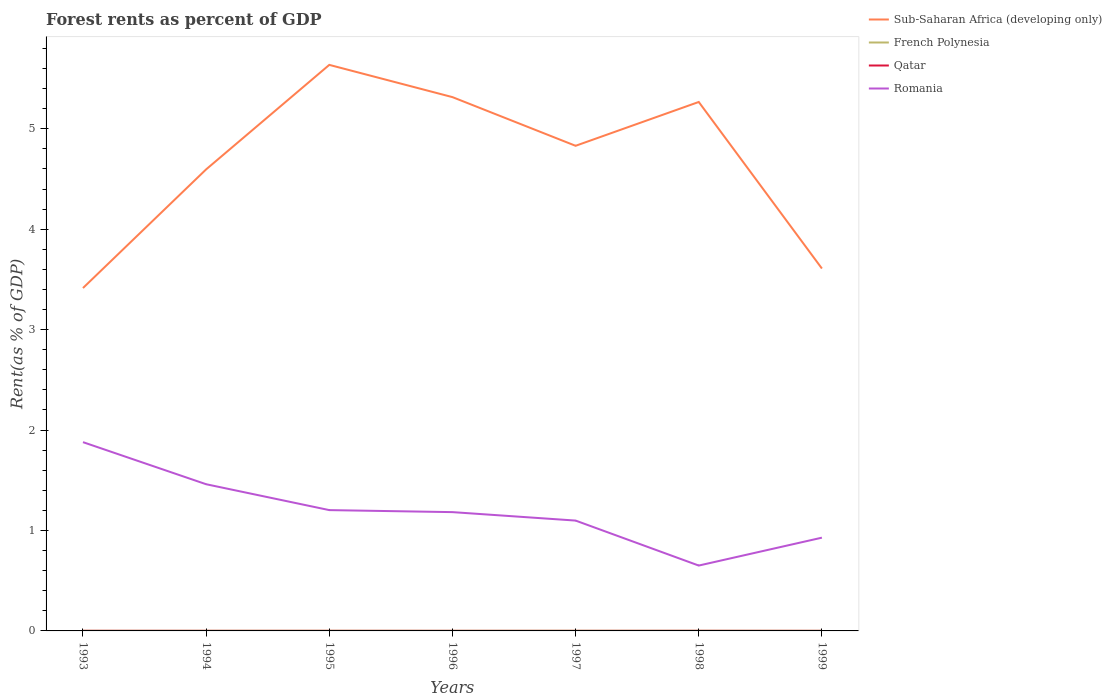Across all years, what is the maximum forest rent in French Polynesia?
Your answer should be compact. 0. In which year was the forest rent in French Polynesia maximum?
Provide a short and direct response. 1993. What is the total forest rent in Qatar in the graph?
Your answer should be compact. 0. What is the difference between the highest and the second highest forest rent in French Polynesia?
Provide a succinct answer. 0. Is the forest rent in Sub-Saharan Africa (developing only) strictly greater than the forest rent in Romania over the years?
Keep it short and to the point. No. How many lines are there?
Make the answer very short. 4. How many years are there in the graph?
Your response must be concise. 7. What is the difference between two consecutive major ticks on the Y-axis?
Give a very brief answer. 1. Are the values on the major ticks of Y-axis written in scientific E-notation?
Offer a very short reply. No. Does the graph contain any zero values?
Offer a terse response. No. How many legend labels are there?
Your response must be concise. 4. How are the legend labels stacked?
Your answer should be compact. Vertical. What is the title of the graph?
Offer a terse response. Forest rents as percent of GDP. Does "Cuba" appear as one of the legend labels in the graph?
Provide a succinct answer. No. What is the label or title of the Y-axis?
Your response must be concise. Rent(as % of GDP). What is the Rent(as % of GDP) of Sub-Saharan Africa (developing only) in 1993?
Your response must be concise. 3.41. What is the Rent(as % of GDP) in French Polynesia in 1993?
Give a very brief answer. 0. What is the Rent(as % of GDP) in Qatar in 1993?
Make the answer very short. 0. What is the Rent(as % of GDP) in Romania in 1993?
Give a very brief answer. 1.88. What is the Rent(as % of GDP) of Sub-Saharan Africa (developing only) in 1994?
Keep it short and to the point. 4.6. What is the Rent(as % of GDP) in French Polynesia in 1994?
Your answer should be compact. 0. What is the Rent(as % of GDP) of Qatar in 1994?
Provide a succinct answer. 0. What is the Rent(as % of GDP) of Romania in 1994?
Offer a very short reply. 1.46. What is the Rent(as % of GDP) of Sub-Saharan Africa (developing only) in 1995?
Your answer should be very brief. 5.64. What is the Rent(as % of GDP) of French Polynesia in 1995?
Offer a very short reply. 0. What is the Rent(as % of GDP) in Qatar in 1995?
Your answer should be very brief. 0. What is the Rent(as % of GDP) of Romania in 1995?
Give a very brief answer. 1.2. What is the Rent(as % of GDP) of Sub-Saharan Africa (developing only) in 1996?
Provide a short and direct response. 5.32. What is the Rent(as % of GDP) in French Polynesia in 1996?
Provide a succinct answer. 0. What is the Rent(as % of GDP) of Qatar in 1996?
Your answer should be compact. 0. What is the Rent(as % of GDP) in Romania in 1996?
Offer a terse response. 1.18. What is the Rent(as % of GDP) of Sub-Saharan Africa (developing only) in 1997?
Your response must be concise. 4.83. What is the Rent(as % of GDP) in French Polynesia in 1997?
Make the answer very short. 0. What is the Rent(as % of GDP) of Qatar in 1997?
Offer a terse response. 0. What is the Rent(as % of GDP) in Romania in 1997?
Provide a short and direct response. 1.1. What is the Rent(as % of GDP) of Sub-Saharan Africa (developing only) in 1998?
Your response must be concise. 5.27. What is the Rent(as % of GDP) in French Polynesia in 1998?
Your answer should be compact. 0. What is the Rent(as % of GDP) in Qatar in 1998?
Your answer should be very brief. 0. What is the Rent(as % of GDP) in Romania in 1998?
Ensure brevity in your answer.  0.65. What is the Rent(as % of GDP) in Sub-Saharan Africa (developing only) in 1999?
Offer a terse response. 3.61. What is the Rent(as % of GDP) in French Polynesia in 1999?
Ensure brevity in your answer.  0. What is the Rent(as % of GDP) of Qatar in 1999?
Give a very brief answer. 0. What is the Rent(as % of GDP) of Romania in 1999?
Offer a very short reply. 0.93. Across all years, what is the maximum Rent(as % of GDP) of Sub-Saharan Africa (developing only)?
Your response must be concise. 5.64. Across all years, what is the maximum Rent(as % of GDP) in French Polynesia?
Offer a terse response. 0. Across all years, what is the maximum Rent(as % of GDP) in Qatar?
Keep it short and to the point. 0. Across all years, what is the maximum Rent(as % of GDP) of Romania?
Give a very brief answer. 1.88. Across all years, what is the minimum Rent(as % of GDP) in Sub-Saharan Africa (developing only)?
Make the answer very short. 3.41. Across all years, what is the minimum Rent(as % of GDP) of French Polynesia?
Ensure brevity in your answer.  0. Across all years, what is the minimum Rent(as % of GDP) of Qatar?
Offer a terse response. 0. Across all years, what is the minimum Rent(as % of GDP) in Romania?
Your response must be concise. 0.65. What is the total Rent(as % of GDP) in Sub-Saharan Africa (developing only) in the graph?
Your answer should be compact. 32.67. What is the total Rent(as % of GDP) of French Polynesia in the graph?
Provide a succinct answer. 0.01. What is the total Rent(as % of GDP) in Qatar in the graph?
Keep it short and to the point. 0.01. What is the total Rent(as % of GDP) in Romania in the graph?
Your response must be concise. 8.4. What is the difference between the Rent(as % of GDP) of Sub-Saharan Africa (developing only) in 1993 and that in 1994?
Make the answer very short. -1.18. What is the difference between the Rent(as % of GDP) in French Polynesia in 1993 and that in 1994?
Give a very brief answer. -0. What is the difference between the Rent(as % of GDP) of Qatar in 1993 and that in 1994?
Keep it short and to the point. 0. What is the difference between the Rent(as % of GDP) of Romania in 1993 and that in 1994?
Offer a very short reply. 0.42. What is the difference between the Rent(as % of GDP) in Sub-Saharan Africa (developing only) in 1993 and that in 1995?
Provide a short and direct response. -2.22. What is the difference between the Rent(as % of GDP) in French Polynesia in 1993 and that in 1995?
Offer a terse response. -0. What is the difference between the Rent(as % of GDP) of Qatar in 1993 and that in 1995?
Give a very brief answer. 0. What is the difference between the Rent(as % of GDP) in Romania in 1993 and that in 1995?
Make the answer very short. 0.68. What is the difference between the Rent(as % of GDP) of Sub-Saharan Africa (developing only) in 1993 and that in 1996?
Ensure brevity in your answer.  -1.9. What is the difference between the Rent(as % of GDP) in French Polynesia in 1993 and that in 1996?
Your answer should be very brief. -0. What is the difference between the Rent(as % of GDP) of Qatar in 1993 and that in 1996?
Your response must be concise. 0. What is the difference between the Rent(as % of GDP) in Romania in 1993 and that in 1996?
Your answer should be very brief. 0.7. What is the difference between the Rent(as % of GDP) of Sub-Saharan Africa (developing only) in 1993 and that in 1997?
Make the answer very short. -1.42. What is the difference between the Rent(as % of GDP) in French Polynesia in 1993 and that in 1997?
Make the answer very short. -0. What is the difference between the Rent(as % of GDP) in Romania in 1993 and that in 1997?
Provide a succinct answer. 0.78. What is the difference between the Rent(as % of GDP) of Sub-Saharan Africa (developing only) in 1993 and that in 1998?
Provide a short and direct response. -1.85. What is the difference between the Rent(as % of GDP) of French Polynesia in 1993 and that in 1998?
Ensure brevity in your answer.  -0. What is the difference between the Rent(as % of GDP) in Romania in 1993 and that in 1998?
Keep it short and to the point. 1.23. What is the difference between the Rent(as % of GDP) of Sub-Saharan Africa (developing only) in 1993 and that in 1999?
Offer a very short reply. -0.19. What is the difference between the Rent(as % of GDP) in French Polynesia in 1993 and that in 1999?
Provide a succinct answer. -0. What is the difference between the Rent(as % of GDP) of Qatar in 1993 and that in 1999?
Keep it short and to the point. 0. What is the difference between the Rent(as % of GDP) in Romania in 1993 and that in 1999?
Give a very brief answer. 0.95. What is the difference between the Rent(as % of GDP) of Sub-Saharan Africa (developing only) in 1994 and that in 1995?
Your answer should be very brief. -1.04. What is the difference between the Rent(as % of GDP) of French Polynesia in 1994 and that in 1995?
Ensure brevity in your answer.  -0. What is the difference between the Rent(as % of GDP) of Qatar in 1994 and that in 1995?
Offer a very short reply. -0. What is the difference between the Rent(as % of GDP) of Romania in 1994 and that in 1995?
Make the answer very short. 0.26. What is the difference between the Rent(as % of GDP) in Sub-Saharan Africa (developing only) in 1994 and that in 1996?
Your response must be concise. -0.72. What is the difference between the Rent(as % of GDP) of Qatar in 1994 and that in 1996?
Offer a very short reply. 0. What is the difference between the Rent(as % of GDP) in Romania in 1994 and that in 1996?
Make the answer very short. 0.28. What is the difference between the Rent(as % of GDP) of Sub-Saharan Africa (developing only) in 1994 and that in 1997?
Offer a very short reply. -0.23. What is the difference between the Rent(as % of GDP) of French Polynesia in 1994 and that in 1997?
Give a very brief answer. -0. What is the difference between the Rent(as % of GDP) of Romania in 1994 and that in 1997?
Your answer should be very brief. 0.36. What is the difference between the Rent(as % of GDP) in Sub-Saharan Africa (developing only) in 1994 and that in 1998?
Keep it short and to the point. -0.67. What is the difference between the Rent(as % of GDP) of French Polynesia in 1994 and that in 1998?
Keep it short and to the point. -0. What is the difference between the Rent(as % of GDP) of Qatar in 1994 and that in 1998?
Your response must be concise. -0. What is the difference between the Rent(as % of GDP) in Romania in 1994 and that in 1998?
Offer a terse response. 0.81. What is the difference between the Rent(as % of GDP) in Sub-Saharan Africa (developing only) in 1994 and that in 1999?
Keep it short and to the point. 0.99. What is the difference between the Rent(as % of GDP) in French Polynesia in 1994 and that in 1999?
Your response must be concise. 0. What is the difference between the Rent(as % of GDP) in Qatar in 1994 and that in 1999?
Your answer should be very brief. 0. What is the difference between the Rent(as % of GDP) of Romania in 1994 and that in 1999?
Offer a terse response. 0.53. What is the difference between the Rent(as % of GDP) of Sub-Saharan Africa (developing only) in 1995 and that in 1996?
Provide a short and direct response. 0.32. What is the difference between the Rent(as % of GDP) of Qatar in 1995 and that in 1996?
Offer a very short reply. 0. What is the difference between the Rent(as % of GDP) of Romania in 1995 and that in 1996?
Provide a succinct answer. 0.02. What is the difference between the Rent(as % of GDP) of Sub-Saharan Africa (developing only) in 1995 and that in 1997?
Give a very brief answer. 0.81. What is the difference between the Rent(as % of GDP) in French Polynesia in 1995 and that in 1997?
Give a very brief answer. -0. What is the difference between the Rent(as % of GDP) of Qatar in 1995 and that in 1997?
Provide a succinct answer. 0. What is the difference between the Rent(as % of GDP) of Romania in 1995 and that in 1997?
Give a very brief answer. 0.1. What is the difference between the Rent(as % of GDP) in Sub-Saharan Africa (developing only) in 1995 and that in 1998?
Your answer should be compact. 0.37. What is the difference between the Rent(as % of GDP) of French Polynesia in 1995 and that in 1998?
Keep it short and to the point. -0. What is the difference between the Rent(as % of GDP) in Qatar in 1995 and that in 1998?
Your response must be concise. -0. What is the difference between the Rent(as % of GDP) of Romania in 1995 and that in 1998?
Provide a succinct answer. 0.55. What is the difference between the Rent(as % of GDP) of Sub-Saharan Africa (developing only) in 1995 and that in 1999?
Your answer should be compact. 2.03. What is the difference between the Rent(as % of GDP) of Qatar in 1995 and that in 1999?
Make the answer very short. 0. What is the difference between the Rent(as % of GDP) of Romania in 1995 and that in 1999?
Offer a terse response. 0.27. What is the difference between the Rent(as % of GDP) of Sub-Saharan Africa (developing only) in 1996 and that in 1997?
Give a very brief answer. 0.48. What is the difference between the Rent(as % of GDP) in French Polynesia in 1996 and that in 1997?
Give a very brief answer. -0. What is the difference between the Rent(as % of GDP) in Qatar in 1996 and that in 1997?
Keep it short and to the point. 0. What is the difference between the Rent(as % of GDP) of Romania in 1996 and that in 1997?
Make the answer very short. 0.08. What is the difference between the Rent(as % of GDP) in Sub-Saharan Africa (developing only) in 1996 and that in 1998?
Make the answer very short. 0.05. What is the difference between the Rent(as % of GDP) in French Polynesia in 1996 and that in 1998?
Your response must be concise. -0. What is the difference between the Rent(as % of GDP) of Qatar in 1996 and that in 1998?
Your answer should be very brief. -0. What is the difference between the Rent(as % of GDP) of Romania in 1996 and that in 1998?
Your answer should be compact. 0.53. What is the difference between the Rent(as % of GDP) of Sub-Saharan Africa (developing only) in 1996 and that in 1999?
Your response must be concise. 1.71. What is the difference between the Rent(as % of GDP) in French Polynesia in 1996 and that in 1999?
Offer a terse response. 0. What is the difference between the Rent(as % of GDP) in Qatar in 1996 and that in 1999?
Ensure brevity in your answer.  0. What is the difference between the Rent(as % of GDP) of Romania in 1996 and that in 1999?
Offer a terse response. 0.25. What is the difference between the Rent(as % of GDP) in Sub-Saharan Africa (developing only) in 1997 and that in 1998?
Your answer should be compact. -0.44. What is the difference between the Rent(as % of GDP) in Qatar in 1997 and that in 1998?
Offer a very short reply. -0. What is the difference between the Rent(as % of GDP) of Romania in 1997 and that in 1998?
Make the answer very short. 0.45. What is the difference between the Rent(as % of GDP) of Sub-Saharan Africa (developing only) in 1997 and that in 1999?
Offer a very short reply. 1.22. What is the difference between the Rent(as % of GDP) in French Polynesia in 1997 and that in 1999?
Ensure brevity in your answer.  0. What is the difference between the Rent(as % of GDP) in Romania in 1997 and that in 1999?
Your answer should be compact. 0.17. What is the difference between the Rent(as % of GDP) in Sub-Saharan Africa (developing only) in 1998 and that in 1999?
Provide a short and direct response. 1.66. What is the difference between the Rent(as % of GDP) in Qatar in 1998 and that in 1999?
Ensure brevity in your answer.  0. What is the difference between the Rent(as % of GDP) of Romania in 1998 and that in 1999?
Your answer should be very brief. -0.28. What is the difference between the Rent(as % of GDP) of Sub-Saharan Africa (developing only) in 1993 and the Rent(as % of GDP) of French Polynesia in 1994?
Keep it short and to the point. 3.41. What is the difference between the Rent(as % of GDP) of Sub-Saharan Africa (developing only) in 1993 and the Rent(as % of GDP) of Qatar in 1994?
Offer a terse response. 3.41. What is the difference between the Rent(as % of GDP) in Sub-Saharan Africa (developing only) in 1993 and the Rent(as % of GDP) in Romania in 1994?
Ensure brevity in your answer.  1.95. What is the difference between the Rent(as % of GDP) of French Polynesia in 1993 and the Rent(as % of GDP) of Romania in 1994?
Keep it short and to the point. -1.46. What is the difference between the Rent(as % of GDP) of Qatar in 1993 and the Rent(as % of GDP) of Romania in 1994?
Keep it short and to the point. -1.46. What is the difference between the Rent(as % of GDP) in Sub-Saharan Africa (developing only) in 1993 and the Rent(as % of GDP) in French Polynesia in 1995?
Your response must be concise. 3.41. What is the difference between the Rent(as % of GDP) in Sub-Saharan Africa (developing only) in 1993 and the Rent(as % of GDP) in Qatar in 1995?
Your answer should be very brief. 3.41. What is the difference between the Rent(as % of GDP) in Sub-Saharan Africa (developing only) in 1993 and the Rent(as % of GDP) in Romania in 1995?
Ensure brevity in your answer.  2.21. What is the difference between the Rent(as % of GDP) in French Polynesia in 1993 and the Rent(as % of GDP) in Romania in 1995?
Make the answer very short. -1.2. What is the difference between the Rent(as % of GDP) in Qatar in 1993 and the Rent(as % of GDP) in Romania in 1995?
Give a very brief answer. -1.2. What is the difference between the Rent(as % of GDP) in Sub-Saharan Africa (developing only) in 1993 and the Rent(as % of GDP) in French Polynesia in 1996?
Offer a terse response. 3.41. What is the difference between the Rent(as % of GDP) in Sub-Saharan Africa (developing only) in 1993 and the Rent(as % of GDP) in Qatar in 1996?
Offer a terse response. 3.41. What is the difference between the Rent(as % of GDP) in Sub-Saharan Africa (developing only) in 1993 and the Rent(as % of GDP) in Romania in 1996?
Give a very brief answer. 2.23. What is the difference between the Rent(as % of GDP) of French Polynesia in 1993 and the Rent(as % of GDP) of Qatar in 1996?
Provide a succinct answer. 0. What is the difference between the Rent(as % of GDP) in French Polynesia in 1993 and the Rent(as % of GDP) in Romania in 1996?
Give a very brief answer. -1.18. What is the difference between the Rent(as % of GDP) in Qatar in 1993 and the Rent(as % of GDP) in Romania in 1996?
Provide a succinct answer. -1.18. What is the difference between the Rent(as % of GDP) in Sub-Saharan Africa (developing only) in 1993 and the Rent(as % of GDP) in French Polynesia in 1997?
Your response must be concise. 3.41. What is the difference between the Rent(as % of GDP) of Sub-Saharan Africa (developing only) in 1993 and the Rent(as % of GDP) of Qatar in 1997?
Your answer should be very brief. 3.41. What is the difference between the Rent(as % of GDP) in Sub-Saharan Africa (developing only) in 1993 and the Rent(as % of GDP) in Romania in 1997?
Your answer should be compact. 2.32. What is the difference between the Rent(as % of GDP) of French Polynesia in 1993 and the Rent(as % of GDP) of Qatar in 1997?
Your answer should be very brief. 0. What is the difference between the Rent(as % of GDP) in French Polynesia in 1993 and the Rent(as % of GDP) in Romania in 1997?
Make the answer very short. -1.1. What is the difference between the Rent(as % of GDP) in Qatar in 1993 and the Rent(as % of GDP) in Romania in 1997?
Your response must be concise. -1.1. What is the difference between the Rent(as % of GDP) of Sub-Saharan Africa (developing only) in 1993 and the Rent(as % of GDP) of French Polynesia in 1998?
Your answer should be compact. 3.41. What is the difference between the Rent(as % of GDP) in Sub-Saharan Africa (developing only) in 1993 and the Rent(as % of GDP) in Qatar in 1998?
Give a very brief answer. 3.41. What is the difference between the Rent(as % of GDP) in Sub-Saharan Africa (developing only) in 1993 and the Rent(as % of GDP) in Romania in 1998?
Ensure brevity in your answer.  2.76. What is the difference between the Rent(as % of GDP) of French Polynesia in 1993 and the Rent(as % of GDP) of Romania in 1998?
Give a very brief answer. -0.65. What is the difference between the Rent(as % of GDP) in Qatar in 1993 and the Rent(as % of GDP) in Romania in 1998?
Your response must be concise. -0.65. What is the difference between the Rent(as % of GDP) in Sub-Saharan Africa (developing only) in 1993 and the Rent(as % of GDP) in French Polynesia in 1999?
Ensure brevity in your answer.  3.41. What is the difference between the Rent(as % of GDP) in Sub-Saharan Africa (developing only) in 1993 and the Rent(as % of GDP) in Qatar in 1999?
Keep it short and to the point. 3.41. What is the difference between the Rent(as % of GDP) of Sub-Saharan Africa (developing only) in 1993 and the Rent(as % of GDP) of Romania in 1999?
Your answer should be compact. 2.49. What is the difference between the Rent(as % of GDP) of French Polynesia in 1993 and the Rent(as % of GDP) of Qatar in 1999?
Your answer should be compact. 0. What is the difference between the Rent(as % of GDP) in French Polynesia in 1993 and the Rent(as % of GDP) in Romania in 1999?
Your response must be concise. -0.93. What is the difference between the Rent(as % of GDP) in Qatar in 1993 and the Rent(as % of GDP) in Romania in 1999?
Offer a terse response. -0.93. What is the difference between the Rent(as % of GDP) of Sub-Saharan Africa (developing only) in 1994 and the Rent(as % of GDP) of French Polynesia in 1995?
Your answer should be very brief. 4.59. What is the difference between the Rent(as % of GDP) in Sub-Saharan Africa (developing only) in 1994 and the Rent(as % of GDP) in Qatar in 1995?
Provide a succinct answer. 4.59. What is the difference between the Rent(as % of GDP) of Sub-Saharan Africa (developing only) in 1994 and the Rent(as % of GDP) of Romania in 1995?
Your answer should be very brief. 3.39. What is the difference between the Rent(as % of GDP) in French Polynesia in 1994 and the Rent(as % of GDP) in Qatar in 1995?
Your answer should be very brief. 0. What is the difference between the Rent(as % of GDP) of French Polynesia in 1994 and the Rent(as % of GDP) of Romania in 1995?
Provide a succinct answer. -1.2. What is the difference between the Rent(as % of GDP) of Qatar in 1994 and the Rent(as % of GDP) of Romania in 1995?
Offer a terse response. -1.2. What is the difference between the Rent(as % of GDP) of Sub-Saharan Africa (developing only) in 1994 and the Rent(as % of GDP) of French Polynesia in 1996?
Offer a very short reply. 4.59. What is the difference between the Rent(as % of GDP) of Sub-Saharan Africa (developing only) in 1994 and the Rent(as % of GDP) of Qatar in 1996?
Your response must be concise. 4.59. What is the difference between the Rent(as % of GDP) in Sub-Saharan Africa (developing only) in 1994 and the Rent(as % of GDP) in Romania in 1996?
Your answer should be very brief. 3.41. What is the difference between the Rent(as % of GDP) in French Polynesia in 1994 and the Rent(as % of GDP) in Qatar in 1996?
Keep it short and to the point. 0. What is the difference between the Rent(as % of GDP) in French Polynesia in 1994 and the Rent(as % of GDP) in Romania in 1996?
Your answer should be very brief. -1.18. What is the difference between the Rent(as % of GDP) in Qatar in 1994 and the Rent(as % of GDP) in Romania in 1996?
Give a very brief answer. -1.18. What is the difference between the Rent(as % of GDP) in Sub-Saharan Africa (developing only) in 1994 and the Rent(as % of GDP) in French Polynesia in 1997?
Keep it short and to the point. 4.59. What is the difference between the Rent(as % of GDP) of Sub-Saharan Africa (developing only) in 1994 and the Rent(as % of GDP) of Qatar in 1997?
Provide a short and direct response. 4.59. What is the difference between the Rent(as % of GDP) of Sub-Saharan Africa (developing only) in 1994 and the Rent(as % of GDP) of Romania in 1997?
Your answer should be compact. 3.5. What is the difference between the Rent(as % of GDP) in French Polynesia in 1994 and the Rent(as % of GDP) in Qatar in 1997?
Offer a terse response. 0. What is the difference between the Rent(as % of GDP) of French Polynesia in 1994 and the Rent(as % of GDP) of Romania in 1997?
Your answer should be very brief. -1.1. What is the difference between the Rent(as % of GDP) in Qatar in 1994 and the Rent(as % of GDP) in Romania in 1997?
Keep it short and to the point. -1.1. What is the difference between the Rent(as % of GDP) of Sub-Saharan Africa (developing only) in 1994 and the Rent(as % of GDP) of French Polynesia in 1998?
Give a very brief answer. 4.59. What is the difference between the Rent(as % of GDP) in Sub-Saharan Africa (developing only) in 1994 and the Rent(as % of GDP) in Qatar in 1998?
Give a very brief answer. 4.59. What is the difference between the Rent(as % of GDP) in Sub-Saharan Africa (developing only) in 1994 and the Rent(as % of GDP) in Romania in 1998?
Make the answer very short. 3.94. What is the difference between the Rent(as % of GDP) in French Polynesia in 1994 and the Rent(as % of GDP) in Romania in 1998?
Ensure brevity in your answer.  -0.65. What is the difference between the Rent(as % of GDP) of Qatar in 1994 and the Rent(as % of GDP) of Romania in 1998?
Ensure brevity in your answer.  -0.65. What is the difference between the Rent(as % of GDP) of Sub-Saharan Africa (developing only) in 1994 and the Rent(as % of GDP) of French Polynesia in 1999?
Your answer should be compact. 4.59. What is the difference between the Rent(as % of GDP) in Sub-Saharan Africa (developing only) in 1994 and the Rent(as % of GDP) in Qatar in 1999?
Keep it short and to the point. 4.59. What is the difference between the Rent(as % of GDP) in Sub-Saharan Africa (developing only) in 1994 and the Rent(as % of GDP) in Romania in 1999?
Ensure brevity in your answer.  3.67. What is the difference between the Rent(as % of GDP) of French Polynesia in 1994 and the Rent(as % of GDP) of Qatar in 1999?
Offer a terse response. 0. What is the difference between the Rent(as % of GDP) in French Polynesia in 1994 and the Rent(as % of GDP) in Romania in 1999?
Ensure brevity in your answer.  -0.93. What is the difference between the Rent(as % of GDP) of Qatar in 1994 and the Rent(as % of GDP) of Romania in 1999?
Provide a short and direct response. -0.93. What is the difference between the Rent(as % of GDP) of Sub-Saharan Africa (developing only) in 1995 and the Rent(as % of GDP) of French Polynesia in 1996?
Offer a terse response. 5.63. What is the difference between the Rent(as % of GDP) in Sub-Saharan Africa (developing only) in 1995 and the Rent(as % of GDP) in Qatar in 1996?
Give a very brief answer. 5.64. What is the difference between the Rent(as % of GDP) of Sub-Saharan Africa (developing only) in 1995 and the Rent(as % of GDP) of Romania in 1996?
Make the answer very short. 4.45. What is the difference between the Rent(as % of GDP) of French Polynesia in 1995 and the Rent(as % of GDP) of Romania in 1996?
Your answer should be very brief. -1.18. What is the difference between the Rent(as % of GDP) in Qatar in 1995 and the Rent(as % of GDP) in Romania in 1996?
Ensure brevity in your answer.  -1.18. What is the difference between the Rent(as % of GDP) in Sub-Saharan Africa (developing only) in 1995 and the Rent(as % of GDP) in French Polynesia in 1997?
Your answer should be very brief. 5.63. What is the difference between the Rent(as % of GDP) in Sub-Saharan Africa (developing only) in 1995 and the Rent(as % of GDP) in Qatar in 1997?
Your answer should be compact. 5.64. What is the difference between the Rent(as % of GDP) of Sub-Saharan Africa (developing only) in 1995 and the Rent(as % of GDP) of Romania in 1997?
Keep it short and to the point. 4.54. What is the difference between the Rent(as % of GDP) of French Polynesia in 1995 and the Rent(as % of GDP) of Romania in 1997?
Offer a very short reply. -1.1. What is the difference between the Rent(as % of GDP) of Qatar in 1995 and the Rent(as % of GDP) of Romania in 1997?
Your answer should be compact. -1.1. What is the difference between the Rent(as % of GDP) of Sub-Saharan Africa (developing only) in 1995 and the Rent(as % of GDP) of French Polynesia in 1998?
Offer a very short reply. 5.63. What is the difference between the Rent(as % of GDP) of Sub-Saharan Africa (developing only) in 1995 and the Rent(as % of GDP) of Qatar in 1998?
Your response must be concise. 5.64. What is the difference between the Rent(as % of GDP) of Sub-Saharan Africa (developing only) in 1995 and the Rent(as % of GDP) of Romania in 1998?
Provide a short and direct response. 4.99. What is the difference between the Rent(as % of GDP) of French Polynesia in 1995 and the Rent(as % of GDP) of Qatar in 1998?
Ensure brevity in your answer.  0. What is the difference between the Rent(as % of GDP) of French Polynesia in 1995 and the Rent(as % of GDP) of Romania in 1998?
Make the answer very short. -0.65. What is the difference between the Rent(as % of GDP) of Qatar in 1995 and the Rent(as % of GDP) of Romania in 1998?
Make the answer very short. -0.65. What is the difference between the Rent(as % of GDP) in Sub-Saharan Africa (developing only) in 1995 and the Rent(as % of GDP) in French Polynesia in 1999?
Your answer should be very brief. 5.63. What is the difference between the Rent(as % of GDP) in Sub-Saharan Africa (developing only) in 1995 and the Rent(as % of GDP) in Qatar in 1999?
Provide a succinct answer. 5.64. What is the difference between the Rent(as % of GDP) in Sub-Saharan Africa (developing only) in 1995 and the Rent(as % of GDP) in Romania in 1999?
Offer a terse response. 4.71. What is the difference between the Rent(as % of GDP) in French Polynesia in 1995 and the Rent(as % of GDP) in Romania in 1999?
Provide a short and direct response. -0.93. What is the difference between the Rent(as % of GDP) of Qatar in 1995 and the Rent(as % of GDP) of Romania in 1999?
Give a very brief answer. -0.93. What is the difference between the Rent(as % of GDP) in Sub-Saharan Africa (developing only) in 1996 and the Rent(as % of GDP) in French Polynesia in 1997?
Your answer should be compact. 5.31. What is the difference between the Rent(as % of GDP) in Sub-Saharan Africa (developing only) in 1996 and the Rent(as % of GDP) in Qatar in 1997?
Provide a short and direct response. 5.31. What is the difference between the Rent(as % of GDP) in Sub-Saharan Africa (developing only) in 1996 and the Rent(as % of GDP) in Romania in 1997?
Your answer should be compact. 4.22. What is the difference between the Rent(as % of GDP) of French Polynesia in 1996 and the Rent(as % of GDP) of Qatar in 1997?
Your response must be concise. 0. What is the difference between the Rent(as % of GDP) of French Polynesia in 1996 and the Rent(as % of GDP) of Romania in 1997?
Provide a short and direct response. -1.1. What is the difference between the Rent(as % of GDP) in Qatar in 1996 and the Rent(as % of GDP) in Romania in 1997?
Offer a terse response. -1.1. What is the difference between the Rent(as % of GDP) in Sub-Saharan Africa (developing only) in 1996 and the Rent(as % of GDP) in French Polynesia in 1998?
Your response must be concise. 5.31. What is the difference between the Rent(as % of GDP) in Sub-Saharan Africa (developing only) in 1996 and the Rent(as % of GDP) in Qatar in 1998?
Offer a terse response. 5.31. What is the difference between the Rent(as % of GDP) of Sub-Saharan Africa (developing only) in 1996 and the Rent(as % of GDP) of Romania in 1998?
Your answer should be compact. 4.66. What is the difference between the Rent(as % of GDP) in French Polynesia in 1996 and the Rent(as % of GDP) in Qatar in 1998?
Ensure brevity in your answer.  0. What is the difference between the Rent(as % of GDP) in French Polynesia in 1996 and the Rent(as % of GDP) in Romania in 1998?
Offer a very short reply. -0.65. What is the difference between the Rent(as % of GDP) of Qatar in 1996 and the Rent(as % of GDP) of Romania in 1998?
Your answer should be compact. -0.65. What is the difference between the Rent(as % of GDP) of Sub-Saharan Africa (developing only) in 1996 and the Rent(as % of GDP) of French Polynesia in 1999?
Your answer should be very brief. 5.31. What is the difference between the Rent(as % of GDP) in Sub-Saharan Africa (developing only) in 1996 and the Rent(as % of GDP) in Qatar in 1999?
Offer a terse response. 5.31. What is the difference between the Rent(as % of GDP) in Sub-Saharan Africa (developing only) in 1996 and the Rent(as % of GDP) in Romania in 1999?
Offer a terse response. 4.39. What is the difference between the Rent(as % of GDP) of French Polynesia in 1996 and the Rent(as % of GDP) of Qatar in 1999?
Make the answer very short. 0. What is the difference between the Rent(as % of GDP) in French Polynesia in 1996 and the Rent(as % of GDP) in Romania in 1999?
Provide a succinct answer. -0.93. What is the difference between the Rent(as % of GDP) of Qatar in 1996 and the Rent(as % of GDP) of Romania in 1999?
Ensure brevity in your answer.  -0.93. What is the difference between the Rent(as % of GDP) of Sub-Saharan Africa (developing only) in 1997 and the Rent(as % of GDP) of French Polynesia in 1998?
Your response must be concise. 4.83. What is the difference between the Rent(as % of GDP) in Sub-Saharan Africa (developing only) in 1997 and the Rent(as % of GDP) in Qatar in 1998?
Your answer should be very brief. 4.83. What is the difference between the Rent(as % of GDP) of Sub-Saharan Africa (developing only) in 1997 and the Rent(as % of GDP) of Romania in 1998?
Make the answer very short. 4.18. What is the difference between the Rent(as % of GDP) in French Polynesia in 1997 and the Rent(as % of GDP) in Qatar in 1998?
Offer a very short reply. 0. What is the difference between the Rent(as % of GDP) in French Polynesia in 1997 and the Rent(as % of GDP) in Romania in 1998?
Offer a terse response. -0.65. What is the difference between the Rent(as % of GDP) of Qatar in 1997 and the Rent(as % of GDP) of Romania in 1998?
Ensure brevity in your answer.  -0.65. What is the difference between the Rent(as % of GDP) of Sub-Saharan Africa (developing only) in 1997 and the Rent(as % of GDP) of French Polynesia in 1999?
Your response must be concise. 4.83. What is the difference between the Rent(as % of GDP) of Sub-Saharan Africa (developing only) in 1997 and the Rent(as % of GDP) of Qatar in 1999?
Your answer should be very brief. 4.83. What is the difference between the Rent(as % of GDP) of Sub-Saharan Africa (developing only) in 1997 and the Rent(as % of GDP) of Romania in 1999?
Your answer should be very brief. 3.9. What is the difference between the Rent(as % of GDP) in French Polynesia in 1997 and the Rent(as % of GDP) in Qatar in 1999?
Your answer should be compact. 0. What is the difference between the Rent(as % of GDP) in French Polynesia in 1997 and the Rent(as % of GDP) in Romania in 1999?
Keep it short and to the point. -0.93. What is the difference between the Rent(as % of GDP) in Qatar in 1997 and the Rent(as % of GDP) in Romania in 1999?
Provide a short and direct response. -0.93. What is the difference between the Rent(as % of GDP) of Sub-Saharan Africa (developing only) in 1998 and the Rent(as % of GDP) of French Polynesia in 1999?
Give a very brief answer. 5.27. What is the difference between the Rent(as % of GDP) in Sub-Saharan Africa (developing only) in 1998 and the Rent(as % of GDP) in Qatar in 1999?
Your response must be concise. 5.27. What is the difference between the Rent(as % of GDP) of Sub-Saharan Africa (developing only) in 1998 and the Rent(as % of GDP) of Romania in 1999?
Provide a short and direct response. 4.34. What is the difference between the Rent(as % of GDP) of French Polynesia in 1998 and the Rent(as % of GDP) of Qatar in 1999?
Provide a short and direct response. 0. What is the difference between the Rent(as % of GDP) of French Polynesia in 1998 and the Rent(as % of GDP) of Romania in 1999?
Your response must be concise. -0.93. What is the difference between the Rent(as % of GDP) in Qatar in 1998 and the Rent(as % of GDP) in Romania in 1999?
Your answer should be compact. -0.93. What is the average Rent(as % of GDP) of Sub-Saharan Africa (developing only) per year?
Provide a short and direct response. 4.67. What is the average Rent(as % of GDP) of French Polynesia per year?
Offer a very short reply. 0. What is the average Rent(as % of GDP) in Qatar per year?
Make the answer very short. 0. What is the average Rent(as % of GDP) in Romania per year?
Your answer should be compact. 1.2. In the year 1993, what is the difference between the Rent(as % of GDP) of Sub-Saharan Africa (developing only) and Rent(as % of GDP) of French Polynesia?
Your response must be concise. 3.41. In the year 1993, what is the difference between the Rent(as % of GDP) in Sub-Saharan Africa (developing only) and Rent(as % of GDP) in Qatar?
Your answer should be compact. 3.41. In the year 1993, what is the difference between the Rent(as % of GDP) of Sub-Saharan Africa (developing only) and Rent(as % of GDP) of Romania?
Keep it short and to the point. 1.53. In the year 1993, what is the difference between the Rent(as % of GDP) in French Polynesia and Rent(as % of GDP) in Romania?
Give a very brief answer. -1.88. In the year 1993, what is the difference between the Rent(as % of GDP) in Qatar and Rent(as % of GDP) in Romania?
Ensure brevity in your answer.  -1.88. In the year 1994, what is the difference between the Rent(as % of GDP) in Sub-Saharan Africa (developing only) and Rent(as % of GDP) in French Polynesia?
Give a very brief answer. 4.59. In the year 1994, what is the difference between the Rent(as % of GDP) of Sub-Saharan Africa (developing only) and Rent(as % of GDP) of Qatar?
Your response must be concise. 4.59. In the year 1994, what is the difference between the Rent(as % of GDP) in Sub-Saharan Africa (developing only) and Rent(as % of GDP) in Romania?
Your answer should be very brief. 3.13. In the year 1994, what is the difference between the Rent(as % of GDP) in French Polynesia and Rent(as % of GDP) in Qatar?
Offer a terse response. 0. In the year 1994, what is the difference between the Rent(as % of GDP) of French Polynesia and Rent(as % of GDP) of Romania?
Ensure brevity in your answer.  -1.46. In the year 1994, what is the difference between the Rent(as % of GDP) of Qatar and Rent(as % of GDP) of Romania?
Keep it short and to the point. -1.46. In the year 1995, what is the difference between the Rent(as % of GDP) in Sub-Saharan Africa (developing only) and Rent(as % of GDP) in French Polynesia?
Ensure brevity in your answer.  5.63. In the year 1995, what is the difference between the Rent(as % of GDP) in Sub-Saharan Africa (developing only) and Rent(as % of GDP) in Qatar?
Your answer should be compact. 5.64. In the year 1995, what is the difference between the Rent(as % of GDP) of Sub-Saharan Africa (developing only) and Rent(as % of GDP) of Romania?
Provide a short and direct response. 4.43. In the year 1995, what is the difference between the Rent(as % of GDP) of French Polynesia and Rent(as % of GDP) of Qatar?
Provide a succinct answer. 0. In the year 1995, what is the difference between the Rent(as % of GDP) of French Polynesia and Rent(as % of GDP) of Romania?
Offer a terse response. -1.2. In the year 1995, what is the difference between the Rent(as % of GDP) in Qatar and Rent(as % of GDP) in Romania?
Offer a very short reply. -1.2. In the year 1996, what is the difference between the Rent(as % of GDP) in Sub-Saharan Africa (developing only) and Rent(as % of GDP) in French Polynesia?
Provide a succinct answer. 5.31. In the year 1996, what is the difference between the Rent(as % of GDP) of Sub-Saharan Africa (developing only) and Rent(as % of GDP) of Qatar?
Make the answer very short. 5.31. In the year 1996, what is the difference between the Rent(as % of GDP) of Sub-Saharan Africa (developing only) and Rent(as % of GDP) of Romania?
Make the answer very short. 4.13. In the year 1996, what is the difference between the Rent(as % of GDP) in French Polynesia and Rent(as % of GDP) in Qatar?
Offer a very short reply. 0. In the year 1996, what is the difference between the Rent(as % of GDP) in French Polynesia and Rent(as % of GDP) in Romania?
Provide a succinct answer. -1.18. In the year 1996, what is the difference between the Rent(as % of GDP) of Qatar and Rent(as % of GDP) of Romania?
Offer a very short reply. -1.18. In the year 1997, what is the difference between the Rent(as % of GDP) of Sub-Saharan Africa (developing only) and Rent(as % of GDP) of French Polynesia?
Ensure brevity in your answer.  4.83. In the year 1997, what is the difference between the Rent(as % of GDP) in Sub-Saharan Africa (developing only) and Rent(as % of GDP) in Qatar?
Offer a very short reply. 4.83. In the year 1997, what is the difference between the Rent(as % of GDP) in Sub-Saharan Africa (developing only) and Rent(as % of GDP) in Romania?
Your response must be concise. 3.73. In the year 1997, what is the difference between the Rent(as % of GDP) of French Polynesia and Rent(as % of GDP) of Qatar?
Keep it short and to the point. 0. In the year 1997, what is the difference between the Rent(as % of GDP) in French Polynesia and Rent(as % of GDP) in Romania?
Keep it short and to the point. -1.1. In the year 1997, what is the difference between the Rent(as % of GDP) of Qatar and Rent(as % of GDP) of Romania?
Ensure brevity in your answer.  -1.1. In the year 1998, what is the difference between the Rent(as % of GDP) in Sub-Saharan Africa (developing only) and Rent(as % of GDP) in French Polynesia?
Offer a very short reply. 5.26. In the year 1998, what is the difference between the Rent(as % of GDP) of Sub-Saharan Africa (developing only) and Rent(as % of GDP) of Qatar?
Provide a succinct answer. 5.27. In the year 1998, what is the difference between the Rent(as % of GDP) in Sub-Saharan Africa (developing only) and Rent(as % of GDP) in Romania?
Give a very brief answer. 4.62. In the year 1998, what is the difference between the Rent(as % of GDP) in French Polynesia and Rent(as % of GDP) in Qatar?
Offer a terse response. 0. In the year 1998, what is the difference between the Rent(as % of GDP) of French Polynesia and Rent(as % of GDP) of Romania?
Make the answer very short. -0.65. In the year 1998, what is the difference between the Rent(as % of GDP) of Qatar and Rent(as % of GDP) of Romania?
Keep it short and to the point. -0.65. In the year 1999, what is the difference between the Rent(as % of GDP) of Sub-Saharan Africa (developing only) and Rent(as % of GDP) of French Polynesia?
Your answer should be very brief. 3.61. In the year 1999, what is the difference between the Rent(as % of GDP) of Sub-Saharan Africa (developing only) and Rent(as % of GDP) of Qatar?
Give a very brief answer. 3.61. In the year 1999, what is the difference between the Rent(as % of GDP) of Sub-Saharan Africa (developing only) and Rent(as % of GDP) of Romania?
Give a very brief answer. 2.68. In the year 1999, what is the difference between the Rent(as % of GDP) of French Polynesia and Rent(as % of GDP) of Qatar?
Offer a very short reply. 0. In the year 1999, what is the difference between the Rent(as % of GDP) of French Polynesia and Rent(as % of GDP) of Romania?
Keep it short and to the point. -0.93. In the year 1999, what is the difference between the Rent(as % of GDP) of Qatar and Rent(as % of GDP) of Romania?
Make the answer very short. -0.93. What is the ratio of the Rent(as % of GDP) of Sub-Saharan Africa (developing only) in 1993 to that in 1994?
Your answer should be very brief. 0.74. What is the ratio of the Rent(as % of GDP) of French Polynesia in 1993 to that in 1994?
Provide a succinct answer. 0.86. What is the ratio of the Rent(as % of GDP) of Qatar in 1993 to that in 1994?
Your response must be concise. 1.41. What is the ratio of the Rent(as % of GDP) of Romania in 1993 to that in 1994?
Keep it short and to the point. 1.29. What is the ratio of the Rent(as % of GDP) of Sub-Saharan Africa (developing only) in 1993 to that in 1995?
Your response must be concise. 0.61. What is the ratio of the Rent(as % of GDP) in French Polynesia in 1993 to that in 1995?
Make the answer very short. 0.79. What is the ratio of the Rent(as % of GDP) of Qatar in 1993 to that in 1995?
Provide a succinct answer. 1.23. What is the ratio of the Rent(as % of GDP) of Romania in 1993 to that in 1995?
Offer a very short reply. 1.56. What is the ratio of the Rent(as % of GDP) in Sub-Saharan Africa (developing only) in 1993 to that in 1996?
Offer a very short reply. 0.64. What is the ratio of the Rent(as % of GDP) of French Polynesia in 1993 to that in 1996?
Provide a succinct answer. 0.93. What is the ratio of the Rent(as % of GDP) in Qatar in 1993 to that in 1996?
Your response must be concise. 1.7. What is the ratio of the Rent(as % of GDP) of Romania in 1993 to that in 1996?
Offer a terse response. 1.59. What is the ratio of the Rent(as % of GDP) in Sub-Saharan Africa (developing only) in 1993 to that in 1997?
Offer a very short reply. 0.71. What is the ratio of the Rent(as % of GDP) in French Polynesia in 1993 to that in 1997?
Keep it short and to the point. 0.72. What is the ratio of the Rent(as % of GDP) in Qatar in 1993 to that in 1997?
Make the answer very short. 1.87. What is the ratio of the Rent(as % of GDP) in Romania in 1993 to that in 1997?
Ensure brevity in your answer.  1.71. What is the ratio of the Rent(as % of GDP) in Sub-Saharan Africa (developing only) in 1993 to that in 1998?
Provide a short and direct response. 0.65. What is the ratio of the Rent(as % of GDP) of French Polynesia in 1993 to that in 1998?
Keep it short and to the point. 0.75. What is the ratio of the Rent(as % of GDP) in Qatar in 1993 to that in 1998?
Offer a terse response. 1.08. What is the ratio of the Rent(as % of GDP) in Romania in 1993 to that in 1998?
Offer a terse response. 2.89. What is the ratio of the Rent(as % of GDP) in Sub-Saharan Africa (developing only) in 1993 to that in 1999?
Offer a terse response. 0.95. What is the ratio of the Rent(as % of GDP) in French Polynesia in 1993 to that in 1999?
Your response must be concise. 1. What is the ratio of the Rent(as % of GDP) of Qatar in 1993 to that in 1999?
Offer a very short reply. 1.72. What is the ratio of the Rent(as % of GDP) in Romania in 1993 to that in 1999?
Offer a terse response. 2.02. What is the ratio of the Rent(as % of GDP) in Sub-Saharan Africa (developing only) in 1994 to that in 1995?
Your response must be concise. 0.82. What is the ratio of the Rent(as % of GDP) in French Polynesia in 1994 to that in 1995?
Your response must be concise. 0.93. What is the ratio of the Rent(as % of GDP) in Qatar in 1994 to that in 1995?
Provide a succinct answer. 0.87. What is the ratio of the Rent(as % of GDP) of Romania in 1994 to that in 1995?
Make the answer very short. 1.21. What is the ratio of the Rent(as % of GDP) in Sub-Saharan Africa (developing only) in 1994 to that in 1996?
Provide a short and direct response. 0.86. What is the ratio of the Rent(as % of GDP) of French Polynesia in 1994 to that in 1996?
Offer a terse response. 1.09. What is the ratio of the Rent(as % of GDP) of Qatar in 1994 to that in 1996?
Provide a succinct answer. 1.2. What is the ratio of the Rent(as % of GDP) in Romania in 1994 to that in 1996?
Offer a terse response. 1.23. What is the ratio of the Rent(as % of GDP) in Sub-Saharan Africa (developing only) in 1994 to that in 1997?
Offer a terse response. 0.95. What is the ratio of the Rent(as % of GDP) of French Polynesia in 1994 to that in 1997?
Offer a very short reply. 0.84. What is the ratio of the Rent(as % of GDP) of Qatar in 1994 to that in 1997?
Ensure brevity in your answer.  1.32. What is the ratio of the Rent(as % of GDP) in Romania in 1994 to that in 1997?
Your answer should be very brief. 1.33. What is the ratio of the Rent(as % of GDP) in Sub-Saharan Africa (developing only) in 1994 to that in 1998?
Your answer should be compact. 0.87. What is the ratio of the Rent(as % of GDP) in French Polynesia in 1994 to that in 1998?
Ensure brevity in your answer.  0.87. What is the ratio of the Rent(as % of GDP) in Qatar in 1994 to that in 1998?
Your answer should be compact. 0.77. What is the ratio of the Rent(as % of GDP) of Romania in 1994 to that in 1998?
Provide a short and direct response. 2.24. What is the ratio of the Rent(as % of GDP) of Sub-Saharan Africa (developing only) in 1994 to that in 1999?
Your response must be concise. 1.27. What is the ratio of the Rent(as % of GDP) of French Polynesia in 1994 to that in 1999?
Your answer should be compact. 1.17. What is the ratio of the Rent(as % of GDP) of Qatar in 1994 to that in 1999?
Your response must be concise. 1.21. What is the ratio of the Rent(as % of GDP) of Romania in 1994 to that in 1999?
Keep it short and to the point. 1.57. What is the ratio of the Rent(as % of GDP) in Sub-Saharan Africa (developing only) in 1995 to that in 1996?
Your response must be concise. 1.06. What is the ratio of the Rent(as % of GDP) in French Polynesia in 1995 to that in 1996?
Provide a succinct answer. 1.17. What is the ratio of the Rent(as % of GDP) of Qatar in 1995 to that in 1996?
Keep it short and to the point. 1.38. What is the ratio of the Rent(as % of GDP) in Sub-Saharan Africa (developing only) in 1995 to that in 1997?
Ensure brevity in your answer.  1.17. What is the ratio of the Rent(as % of GDP) of French Polynesia in 1995 to that in 1997?
Your response must be concise. 0.9. What is the ratio of the Rent(as % of GDP) of Qatar in 1995 to that in 1997?
Offer a very short reply. 1.52. What is the ratio of the Rent(as % of GDP) of Romania in 1995 to that in 1997?
Ensure brevity in your answer.  1.09. What is the ratio of the Rent(as % of GDP) in Sub-Saharan Africa (developing only) in 1995 to that in 1998?
Offer a very short reply. 1.07. What is the ratio of the Rent(as % of GDP) in French Polynesia in 1995 to that in 1998?
Offer a terse response. 0.94. What is the ratio of the Rent(as % of GDP) in Qatar in 1995 to that in 1998?
Ensure brevity in your answer.  0.88. What is the ratio of the Rent(as % of GDP) in Romania in 1995 to that in 1998?
Give a very brief answer. 1.85. What is the ratio of the Rent(as % of GDP) of Sub-Saharan Africa (developing only) in 1995 to that in 1999?
Give a very brief answer. 1.56. What is the ratio of the Rent(as % of GDP) in French Polynesia in 1995 to that in 1999?
Make the answer very short. 1.26. What is the ratio of the Rent(as % of GDP) of Qatar in 1995 to that in 1999?
Your response must be concise. 1.4. What is the ratio of the Rent(as % of GDP) of Romania in 1995 to that in 1999?
Keep it short and to the point. 1.3. What is the ratio of the Rent(as % of GDP) in Sub-Saharan Africa (developing only) in 1996 to that in 1997?
Provide a short and direct response. 1.1. What is the ratio of the Rent(as % of GDP) of French Polynesia in 1996 to that in 1997?
Give a very brief answer. 0.77. What is the ratio of the Rent(as % of GDP) of Qatar in 1996 to that in 1997?
Ensure brevity in your answer.  1.1. What is the ratio of the Rent(as % of GDP) in Romania in 1996 to that in 1997?
Your response must be concise. 1.08. What is the ratio of the Rent(as % of GDP) in Sub-Saharan Africa (developing only) in 1996 to that in 1998?
Your answer should be compact. 1.01. What is the ratio of the Rent(as % of GDP) of French Polynesia in 1996 to that in 1998?
Provide a succinct answer. 0.8. What is the ratio of the Rent(as % of GDP) of Qatar in 1996 to that in 1998?
Ensure brevity in your answer.  0.64. What is the ratio of the Rent(as % of GDP) of Romania in 1996 to that in 1998?
Provide a short and direct response. 1.82. What is the ratio of the Rent(as % of GDP) of Sub-Saharan Africa (developing only) in 1996 to that in 1999?
Provide a short and direct response. 1.47. What is the ratio of the Rent(as % of GDP) of French Polynesia in 1996 to that in 1999?
Your response must be concise. 1.07. What is the ratio of the Rent(as % of GDP) of Qatar in 1996 to that in 1999?
Offer a very short reply. 1.01. What is the ratio of the Rent(as % of GDP) of Romania in 1996 to that in 1999?
Your answer should be very brief. 1.27. What is the ratio of the Rent(as % of GDP) in Sub-Saharan Africa (developing only) in 1997 to that in 1998?
Provide a short and direct response. 0.92. What is the ratio of the Rent(as % of GDP) of French Polynesia in 1997 to that in 1998?
Make the answer very short. 1.04. What is the ratio of the Rent(as % of GDP) in Qatar in 1997 to that in 1998?
Your answer should be very brief. 0.58. What is the ratio of the Rent(as % of GDP) of Romania in 1997 to that in 1998?
Your answer should be very brief. 1.69. What is the ratio of the Rent(as % of GDP) in Sub-Saharan Africa (developing only) in 1997 to that in 1999?
Ensure brevity in your answer.  1.34. What is the ratio of the Rent(as % of GDP) in French Polynesia in 1997 to that in 1999?
Give a very brief answer. 1.39. What is the ratio of the Rent(as % of GDP) in Qatar in 1997 to that in 1999?
Ensure brevity in your answer.  0.92. What is the ratio of the Rent(as % of GDP) in Romania in 1997 to that in 1999?
Provide a short and direct response. 1.18. What is the ratio of the Rent(as % of GDP) of Sub-Saharan Africa (developing only) in 1998 to that in 1999?
Ensure brevity in your answer.  1.46. What is the ratio of the Rent(as % of GDP) of French Polynesia in 1998 to that in 1999?
Ensure brevity in your answer.  1.33. What is the ratio of the Rent(as % of GDP) of Qatar in 1998 to that in 1999?
Your answer should be compact. 1.58. What is the ratio of the Rent(as % of GDP) in Romania in 1998 to that in 1999?
Your answer should be compact. 0.7. What is the difference between the highest and the second highest Rent(as % of GDP) in Sub-Saharan Africa (developing only)?
Give a very brief answer. 0.32. What is the difference between the highest and the second highest Rent(as % of GDP) in French Polynesia?
Give a very brief answer. 0. What is the difference between the highest and the second highest Rent(as % of GDP) of Qatar?
Your answer should be very brief. 0. What is the difference between the highest and the second highest Rent(as % of GDP) in Romania?
Provide a succinct answer. 0.42. What is the difference between the highest and the lowest Rent(as % of GDP) of Sub-Saharan Africa (developing only)?
Provide a short and direct response. 2.22. What is the difference between the highest and the lowest Rent(as % of GDP) of French Polynesia?
Your response must be concise. 0. What is the difference between the highest and the lowest Rent(as % of GDP) of Qatar?
Provide a short and direct response. 0. What is the difference between the highest and the lowest Rent(as % of GDP) in Romania?
Your response must be concise. 1.23. 